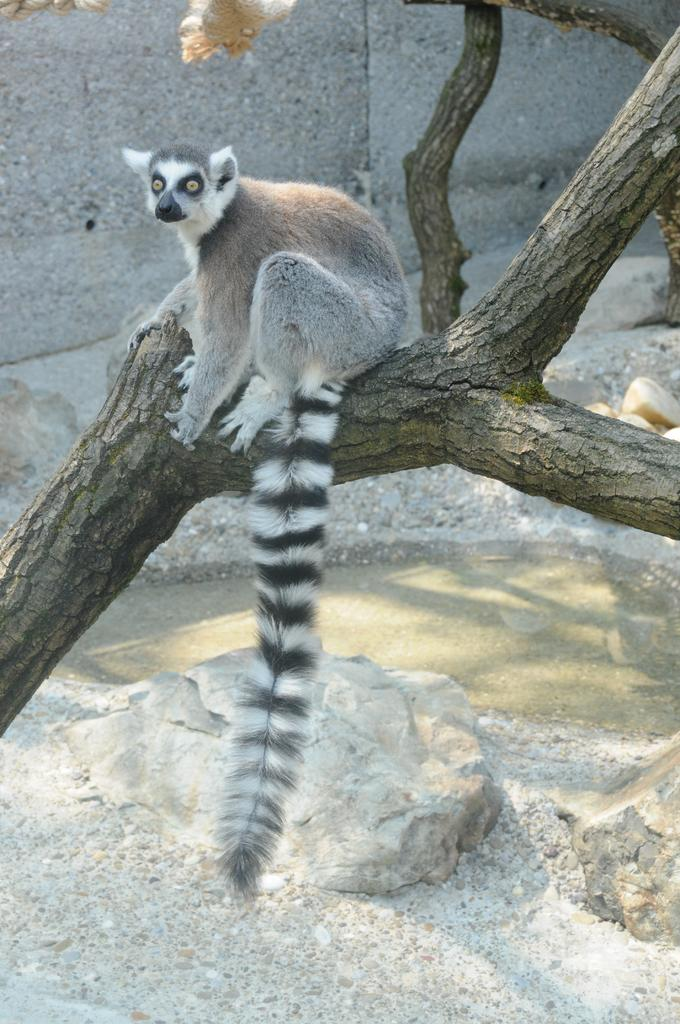What is on the trunk of the tree in the image? There is an animal visible on the trunk of a tree. What is located under the trunk of the tree? Water is visible under the trunk of the tree. What can be found near the water in the image? Stones are present near the water. What is visible at the top of the image? There is a wall visible at the top of the image. How much value does the grass in the image have? There is no grass present in the image, so it is not possible to determine its value. Can you tell me how the animal is swimming in the image? The animal is not swimming in the image; it is on the trunk of the tree. 